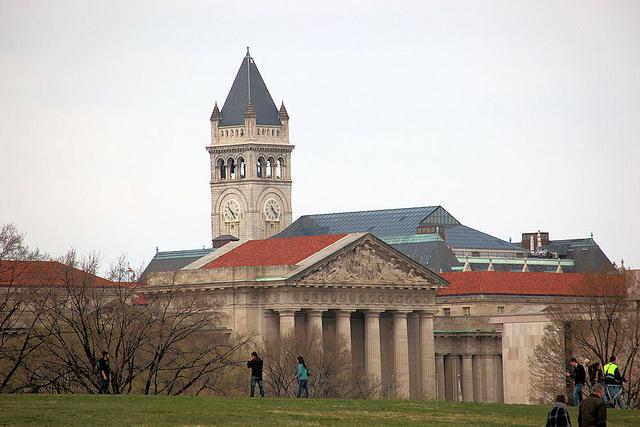Is this a castle?
Concise answer only. No. What type of building is this?
Short answer required. Church. What type of roof is that?
Write a very short answer. Tile. Is there a glass house?
Concise answer only. No. How is the sky?
Write a very short answer. Clear. Does anyone live in there?
Short answer required. No. 